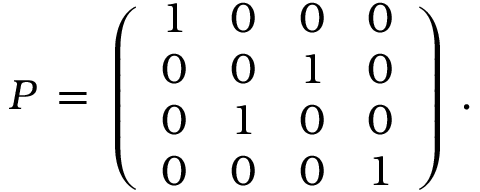<formula> <loc_0><loc_0><loc_500><loc_500>P \, = \, \left ( \begin{array} { c c c c } { 1 } & { 0 } & { 0 } & { 0 } \\ { 0 } & { 0 } & { 1 } & { 0 } \\ { 0 } & { 1 } & { 0 } & { 0 } \\ { 0 } & { 0 } & { 0 } & { 1 } \end{array} \right ) \, .</formula> 